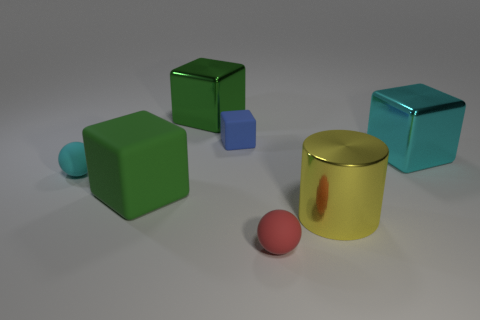What number of other small objects are the same material as the small cyan thing?
Give a very brief answer. 2. What is the color of the big block that is the same material as the small blue block?
Provide a succinct answer. Green. Is the size of the red rubber object the same as the cube in front of the small cyan ball?
Offer a very short reply. No. What is the shape of the big yellow object?
Your answer should be very brief. Cylinder. What number of big things have the same color as the cylinder?
Your response must be concise. 0. There is another metal object that is the same shape as the green metallic object; what is its color?
Provide a short and direct response. Cyan. There is a big block right of the small blue matte block; what number of yellow things are behind it?
Keep it short and to the point. 0. What number of balls are large green objects or large things?
Offer a terse response. 0. Are any metal cylinders visible?
Provide a succinct answer. Yes. There is a blue rubber object that is the same shape as the cyan metallic object; what size is it?
Make the answer very short. Small. 